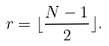<formula> <loc_0><loc_0><loc_500><loc_500>r = \lfloor \frac { N - 1 } { 2 } \rfloor .</formula> 